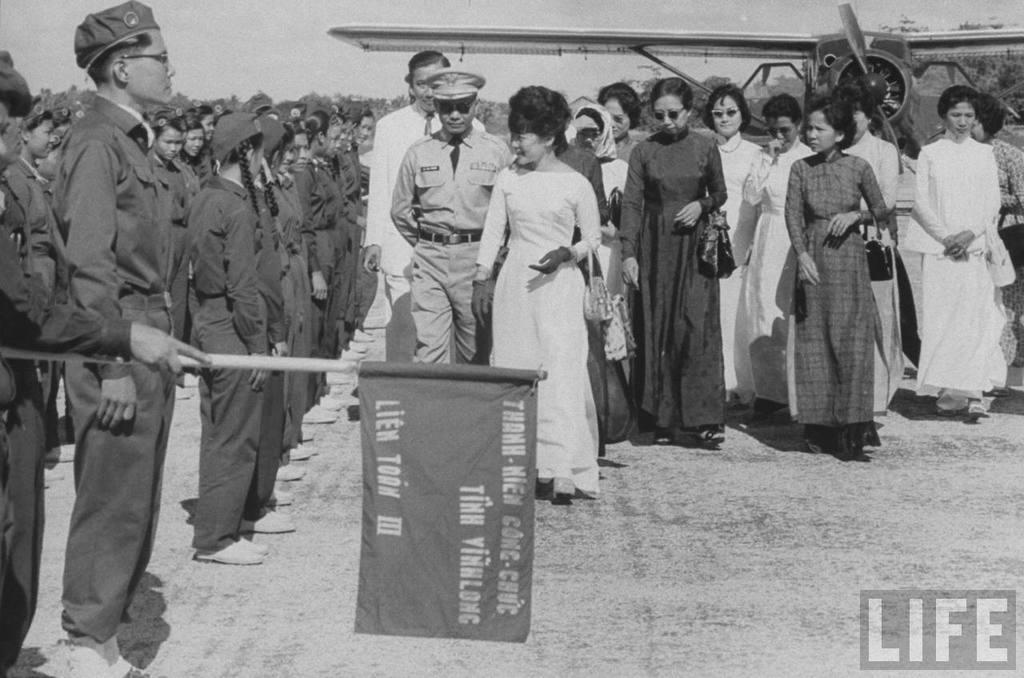<image>
Present a compact description of the photo's key features. Soldier holding a flag which says "Lien Toan" on it. 